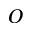Convert formula to latex. <formula><loc_0><loc_0><loc_500><loc_500>O</formula> 